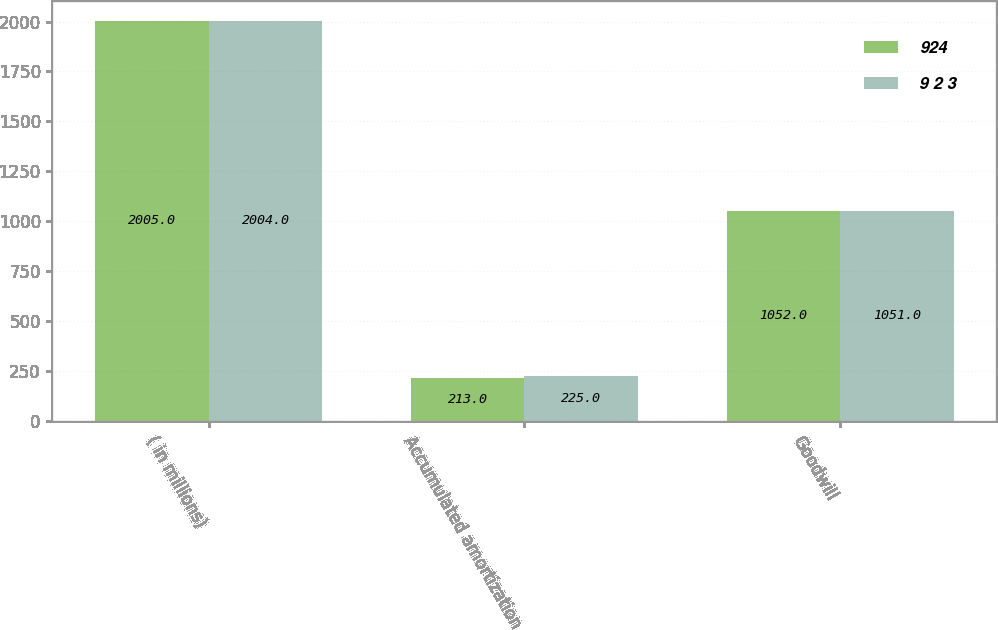Convert chart. <chart><loc_0><loc_0><loc_500><loc_500><stacked_bar_chart><ecel><fcel>( in millions)<fcel>Accumulated amortization<fcel>Goodwill<nl><fcel>924<fcel>2005<fcel>213<fcel>1052<nl><fcel>9 2 3<fcel>2004<fcel>225<fcel>1051<nl></chart> 